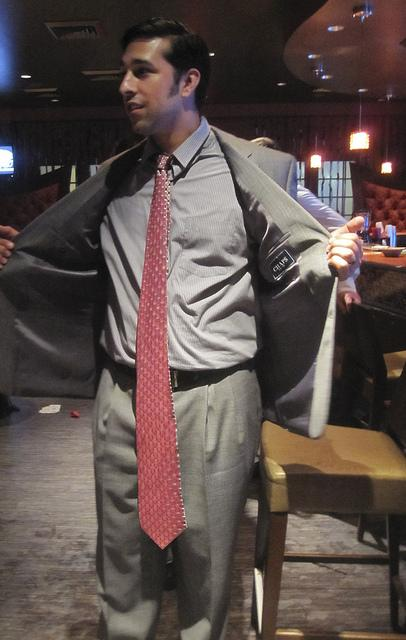What is the problem with this tie? too long 